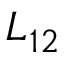Convert formula to latex. <formula><loc_0><loc_0><loc_500><loc_500>L _ { 1 2 }</formula> 